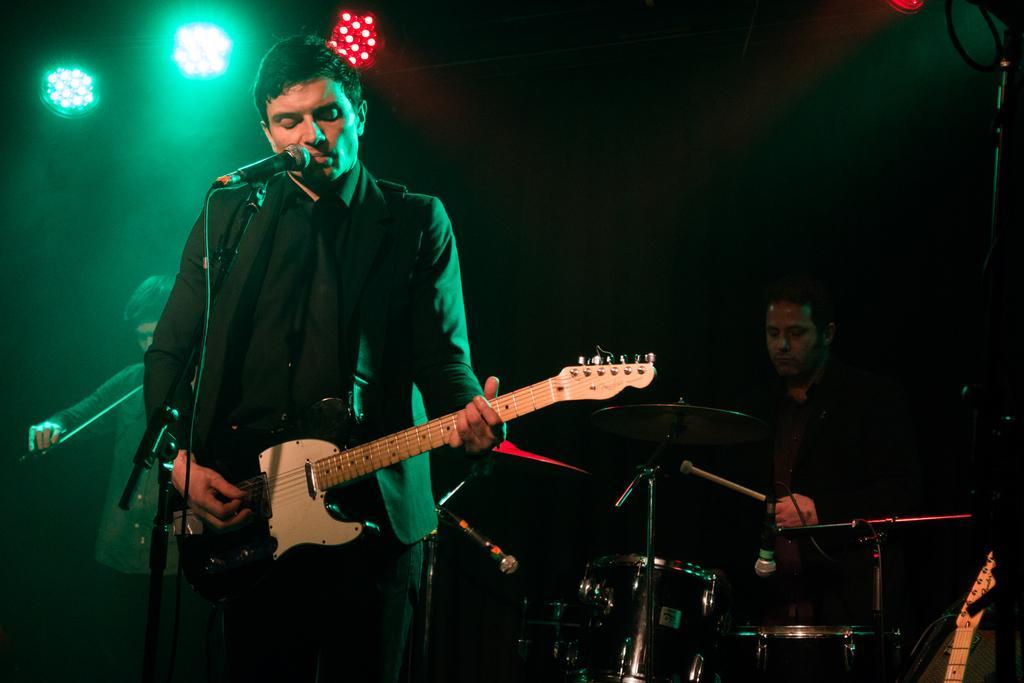Describe this image in one or two sentences. This man is playing guitar and singing in-front of mic. On top there are lights. This person is standing and playing these musical instrument with stick. In-front of this musical instrument there is a mic. 